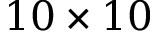<formula> <loc_0><loc_0><loc_500><loc_500>1 0 \times 1 0</formula> 